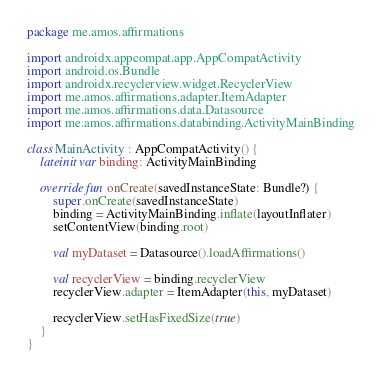<code> <loc_0><loc_0><loc_500><loc_500><_Kotlin_>package me.amos.affirmations

import androidx.appcompat.app.AppCompatActivity
import android.os.Bundle
import androidx.recyclerview.widget.RecyclerView
import me.amos.affirmations.adapter.ItemAdapter
import me.amos.affirmations.data.Datasource
import me.amos.affirmations.databinding.ActivityMainBinding

class MainActivity : AppCompatActivity() {
    lateinit var binding: ActivityMainBinding

    override fun onCreate(savedInstanceState: Bundle?) {
        super.onCreate(savedInstanceState)
        binding = ActivityMainBinding.inflate(layoutInflater)
        setContentView(binding.root)

        val myDataset = Datasource().loadAffirmations()

        val recyclerView = binding.recyclerView
        recyclerView.adapter = ItemAdapter(this, myDataset)

        recyclerView.setHasFixedSize(true)
    }
}</code> 